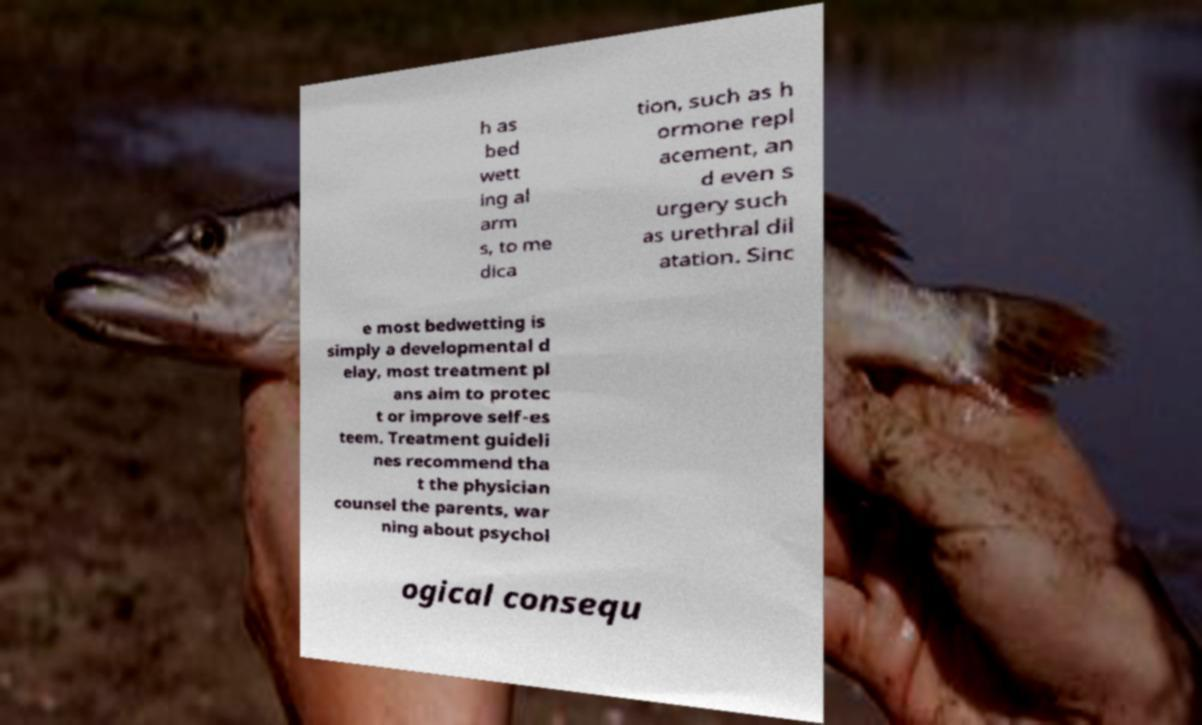Could you assist in decoding the text presented in this image and type it out clearly? h as bed wett ing al arm s, to me dica tion, such as h ormone repl acement, an d even s urgery such as urethral dil atation. Sinc e most bedwetting is simply a developmental d elay, most treatment pl ans aim to protec t or improve self-es teem. Treatment guideli nes recommend tha t the physician counsel the parents, war ning about psychol ogical consequ 